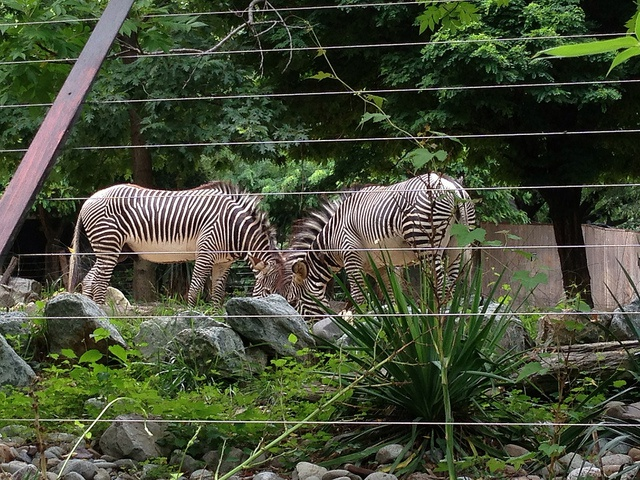Describe the objects in this image and their specific colors. I can see zebra in olive, black, white, gray, and darkgray tones and zebra in olive, black, gray, darkgray, and lightgray tones in this image. 